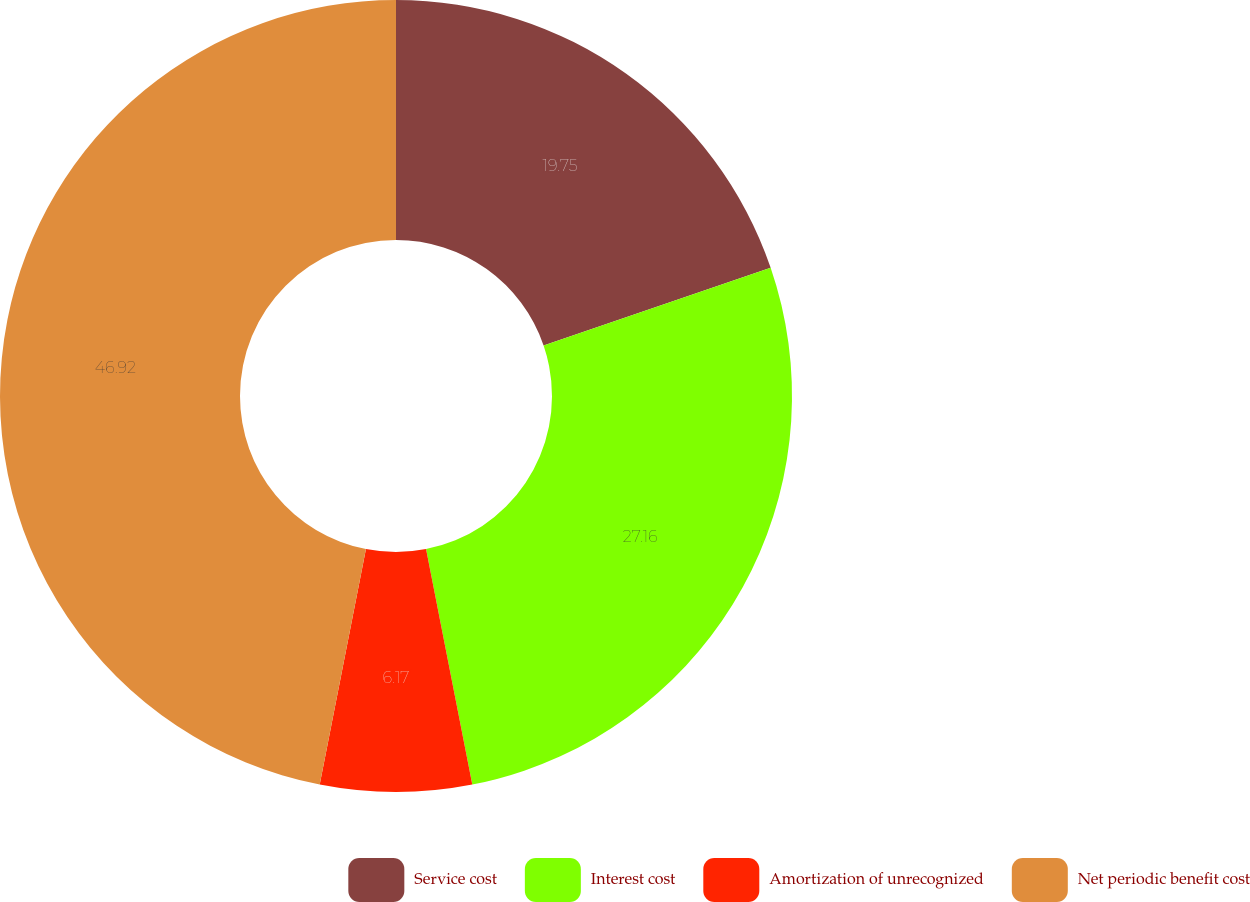Convert chart to OTSL. <chart><loc_0><loc_0><loc_500><loc_500><pie_chart><fcel>Service cost<fcel>Interest cost<fcel>Amortization of unrecognized<fcel>Net periodic benefit cost<nl><fcel>19.75%<fcel>27.16%<fcel>6.17%<fcel>46.91%<nl></chart> 